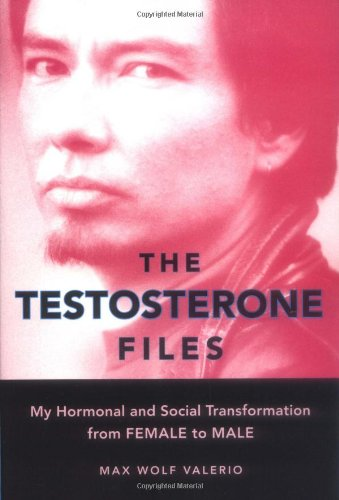Describe the main focus of the book depicted in the image. The main focus of the book is on the author's gender transition from female to male, capturing the psychological and societal impacts of hormonal therapy and identity shifts. 